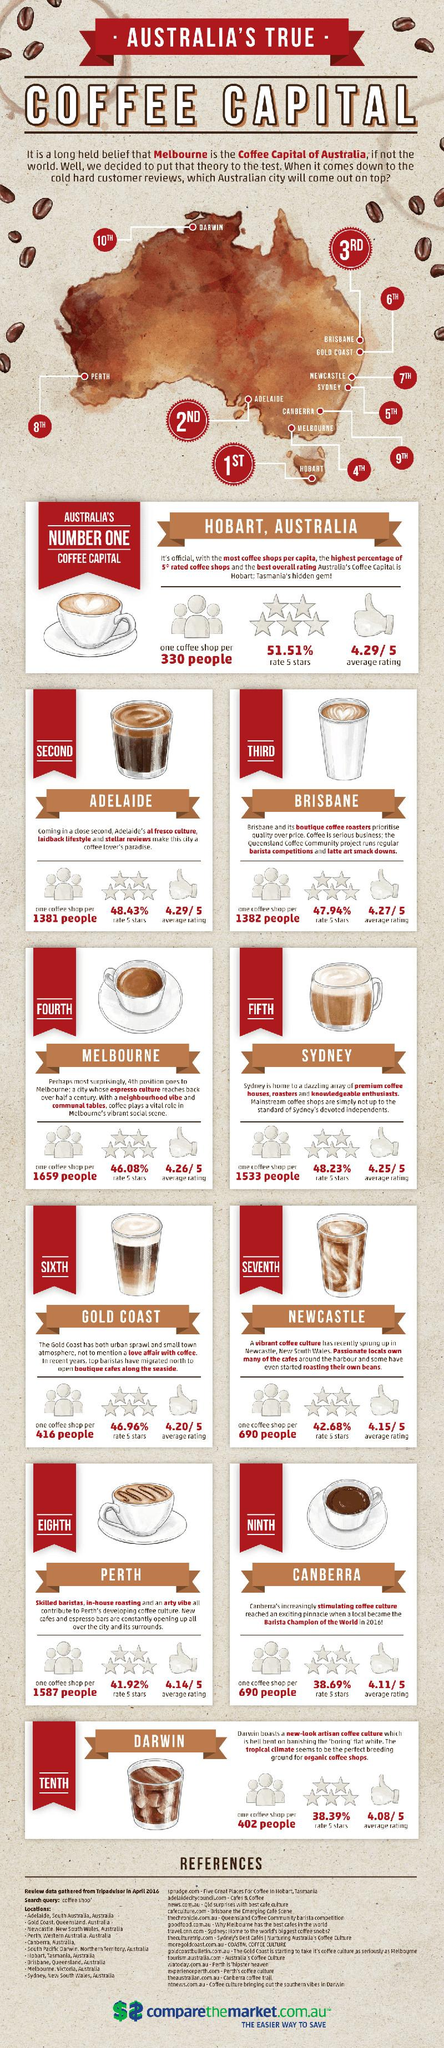Specify some key components in this picture. The number of references cited is fifteen. Melbourne has one coffee shop for every 1,659 people, making it the city with the highest number of coffee shops per capita. The infographic depicts approximately 10 coffee cups, mugs, and glasses. Brisbane is ranked third in coffee customer reviews. Hobart, the isolated city, is the best coffee spot in Australia. 